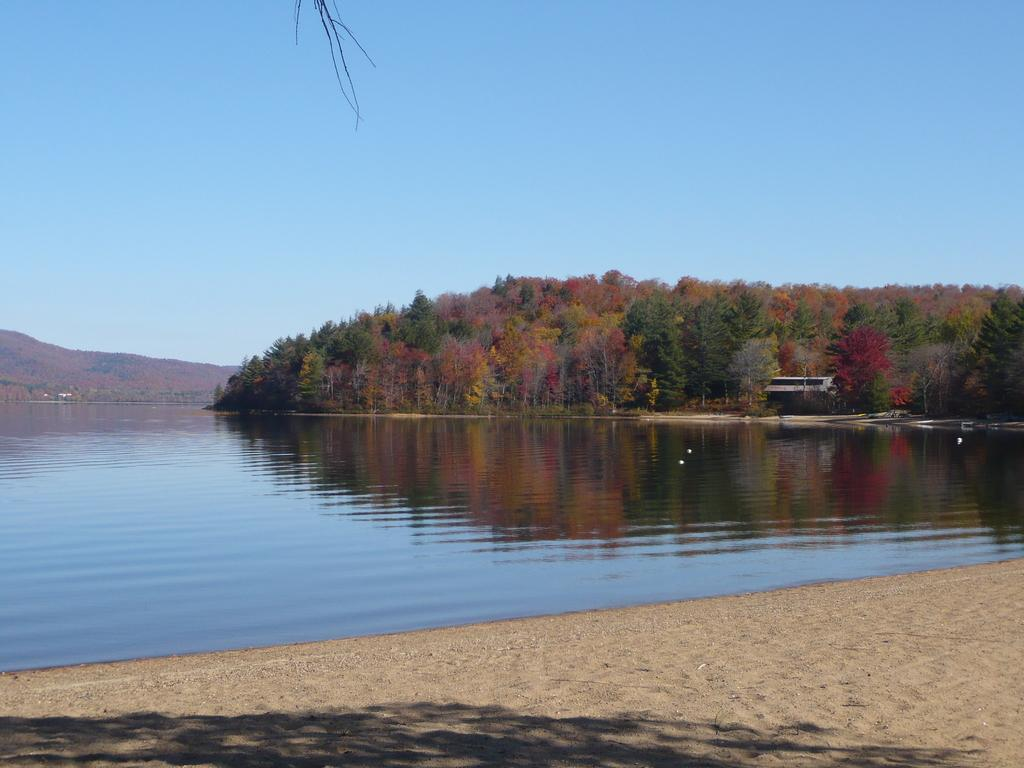What type of natural feature is present in the image? There is a river in the image. What other natural elements can be seen in the image? There are trees and a mountain visible in the image. What type of joke is being told by the mountain in the image? There is no joke being told by the mountain in the image, as mountains do not have the ability to speak or tell jokes. 